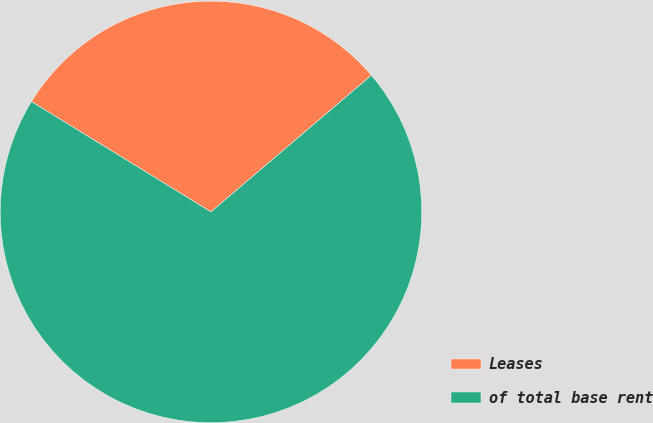Convert chart to OTSL. <chart><loc_0><loc_0><loc_500><loc_500><pie_chart><fcel>Leases<fcel>of total base rent<nl><fcel>30.0%<fcel>70.0%<nl></chart> 